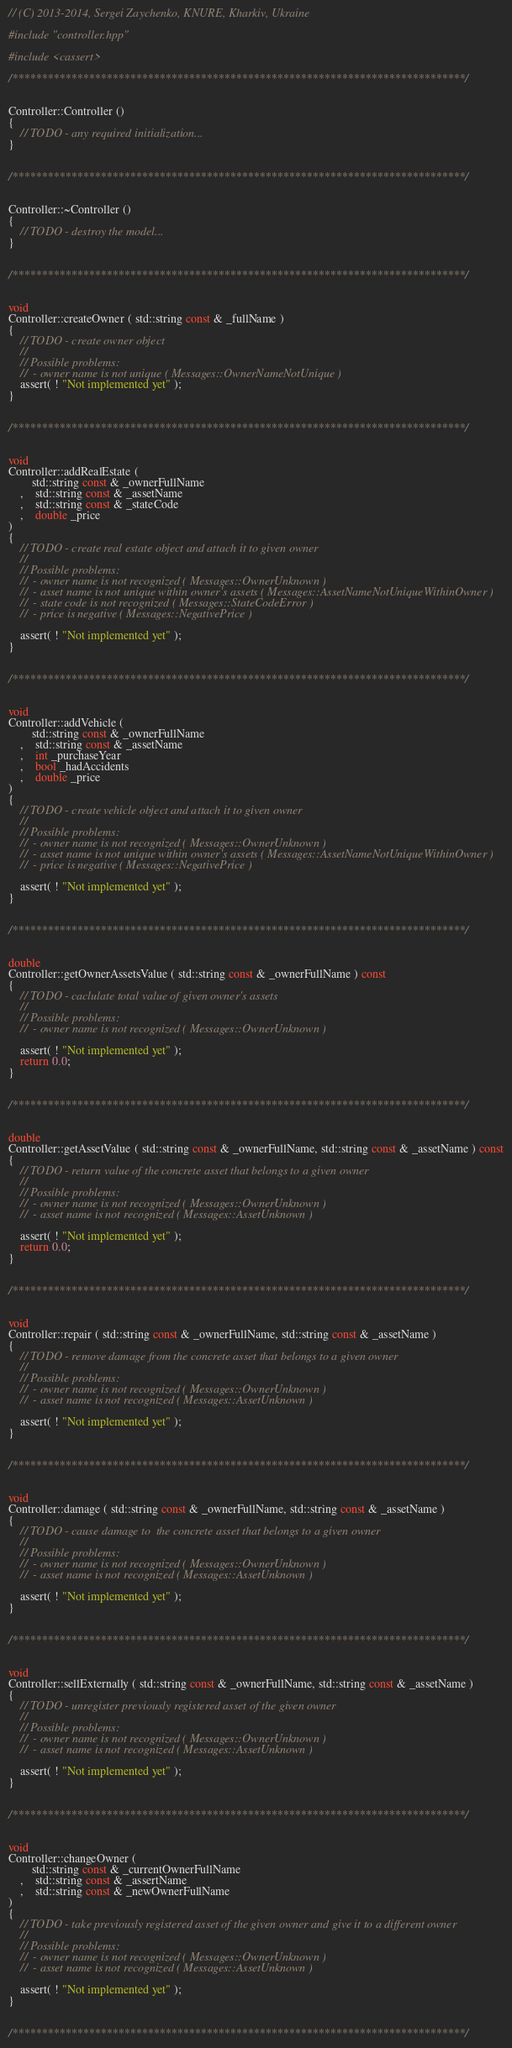<code> <loc_0><loc_0><loc_500><loc_500><_C++_>// (C) 2013-2014, Sergei Zaychenko, KNURE, Kharkiv, Ukraine

#include "controller.hpp"

#include <cassert>

/*****************************************************************************/


Controller::Controller ()
{
	// TODO - any required initialization...
}


/*****************************************************************************/


Controller::~Controller ()
{
	// TODO - destroy the model...
}


/*****************************************************************************/


void 
Controller::createOwner ( std::string const & _fullName )
{
	// TODO - create owner object
	//
	// Possible problems:
	//  - owner name is not unique ( Messages::OwnerNameNotUnique )
	assert( ! "Not implemented yet" );
}


/*****************************************************************************/

	
void 
Controller::addRealEstate ( 
		std::string const & _ownerFullName
	,	std::string const & _assetName
	,	std::string const & _stateCode
	,	double _price
)
{
	// TODO - create real estate object and attach it to given owner
	//
	// Possible problems:
	//  - owner name is not recognized ( Messages::OwnerUnknown )
	//  - asset name is not unique within owner's assets ( Messages::AssetNameNotUniqueWithinOwner )
	//  - state code is not recognized ( Messages::StateCodeError )
	//	- price is negative ( Messages::NegativePrice )

	assert( ! "Not implemented yet" );
}


/*****************************************************************************/


void 
Controller::addVehicle (
		std::string const & _ownerFullName
	,	std::string const & _assetName
	,	int _purchaseYear
	,	bool _hadAccidents
	,	double _price
)
{
	// TODO - create vehicle object and attach it to given owner
	//
	// Possible problems:
	//  - owner name is not recognized ( Messages::OwnerUnknown )
	//  - asset name is not unique within owner's assets ( Messages::AssetNameNotUniqueWithinOwner )
	//	- price is negative ( Messages::NegativePrice )

	assert( ! "Not implemented yet" );
}


/*****************************************************************************/


double
Controller::getOwnerAssetsValue ( std::string const & _ownerFullName ) const
{
	// TODO - caclulate total value of given owner's assets
	//
	// Possible problems:
	//  - owner name is not recognized ( Messages::OwnerUnknown )

	assert( ! "Not implemented yet" );
	return 0.0;
}


/*****************************************************************************/


double 
Controller::getAssetValue ( std::string const & _ownerFullName, std::string const & _assetName ) const
{
	// TODO - return value of the concrete asset that belongs to a given owner
	//
	// Possible problems:
	//  - owner name is not recognized ( Messages::OwnerUnknown )
	//	- asset name is not recognized ( Messages::AssetUnknown )

	assert( ! "Not implemented yet" );
	return 0.0;
}


/*****************************************************************************/


void 
Controller::repair ( std::string const & _ownerFullName, std::string const & _assetName )
{
	// TODO - remove damage from the concrete asset that belongs to a given owner
	//
	// Possible problems:
	//  - owner name is not recognized ( Messages::OwnerUnknown )
	//	- asset name is not recognized ( Messages::AssetUnknown )

	assert( ! "Not implemented yet" );
}
	

/*****************************************************************************/


void
Controller::damage ( std::string const & _ownerFullName, std::string const & _assetName )
{
	// TODO - cause damage to  the concrete asset that belongs to a given owner
	//
	// Possible problems:
	//  - owner name is not recognized ( Messages::OwnerUnknown )
	//	- asset name is not recognized ( Messages::AssetUnknown )

	assert( ! "Not implemented yet" );
}


/*****************************************************************************/


void 
Controller::sellExternally ( std::string const & _ownerFullName, std::string const & _assetName )
{
	// TODO - unregister previously registered asset of the given owner
	//
	// Possible problems:
	//  - owner name is not recognized ( Messages::OwnerUnknown )
	//	- asset name is not recognized ( Messages::AssetUnknown )

	assert( ! "Not implemented yet" );
}


/*****************************************************************************/


void 
Controller::changeOwner ( 
		std::string const & _currentOwnerFullName
	,	std::string const & _assertName
	,	std::string const & _newOwnerFullName
)
{
	// TODO - take previously registered asset of the given owner and give it to a different owner
	//
	// Possible problems:
	//  - owner name is not recognized ( Messages::OwnerUnknown )
	//	- asset name is not recognized ( Messages::AssetUnknown )

	assert( ! "Not implemented yet" );
}


/*****************************************************************************/
</code> 